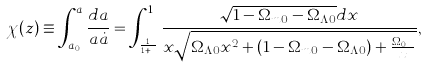<formula> <loc_0><loc_0><loc_500><loc_500>\chi ( z ) \equiv \int _ { a _ { 0 } } ^ { a } \frac { d a } { a \dot { a } } = \int _ { \frac { 1 } { 1 + z } } ^ { 1 } \frac { \sqrt { 1 - \Omega _ { m 0 } - \Omega _ { \Lambda 0 } } d x } { x \sqrt { \Omega _ { \Lambda 0 } x ^ { 2 } + ( 1 - \Omega _ { m 0 } - \Omega _ { \Lambda 0 } ) + \frac { \Omega _ { m 0 } } { x } } } ,</formula> 